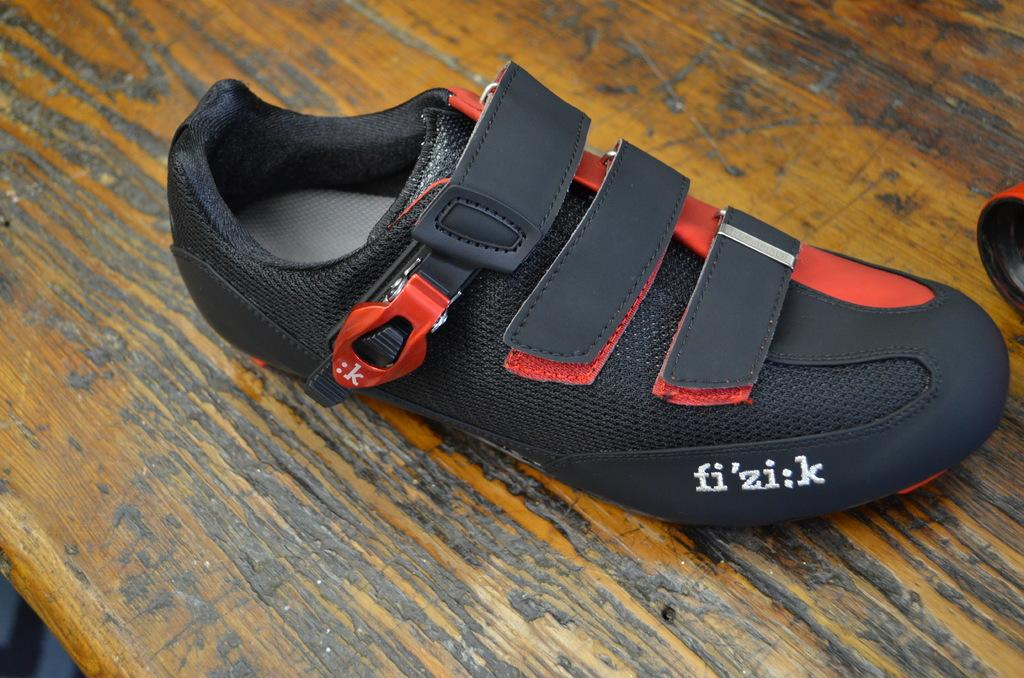What object is in the image? There is a shoe in the image. What color is the shoe? The shoe is black in color. Where is the shoe located in the image? The shoe is placed on a table. What type of badge is attached to the shoe in the image? There is no badge attached to the shoe in the image; it is just a black shoe placed on a table. 